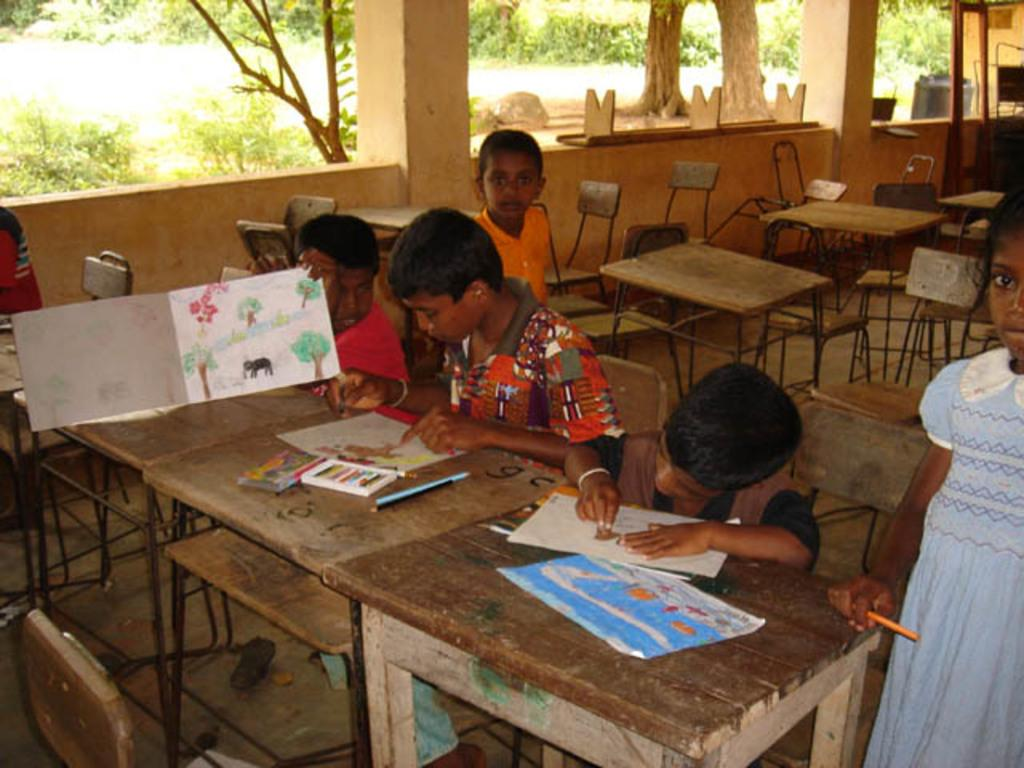Who is present in the image? There are children in the image. What are the children doing in the image? The children are sitting on chairs and drawing on paper. What is in front of the chairs? There are benches in front of the chairs. What can be seen in the background of the image? There is greenery visible in the background of the image. What type of trucks can be seen in the image? There are no trucks present in the image. Where are the children going on vacation in the image? The image does not depict a vacation or any travel plans; it shows children drawing on chairs. Is there a scarecrow visible in the image? There is no scarecrow present in the image. 